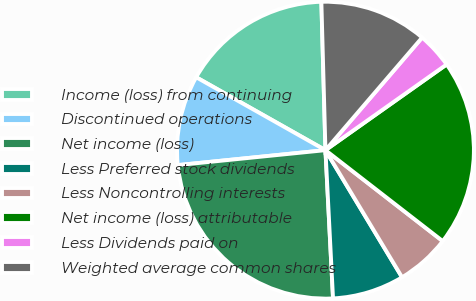Convert chart to OTSL. <chart><loc_0><loc_0><loc_500><loc_500><pie_chart><fcel>Income (loss) from continuing<fcel>Discontinued operations<fcel>Net income (loss)<fcel>Less Preferred stock dividends<fcel>Less Noncontrolling interests<fcel>Net income (loss) attributable<fcel>Less Dividends paid on<fcel>Weighted average common shares<nl><fcel>16.39%<fcel>9.78%<fcel>24.21%<fcel>7.82%<fcel>5.87%<fcel>20.3%<fcel>3.91%<fcel>11.73%<nl></chart> 